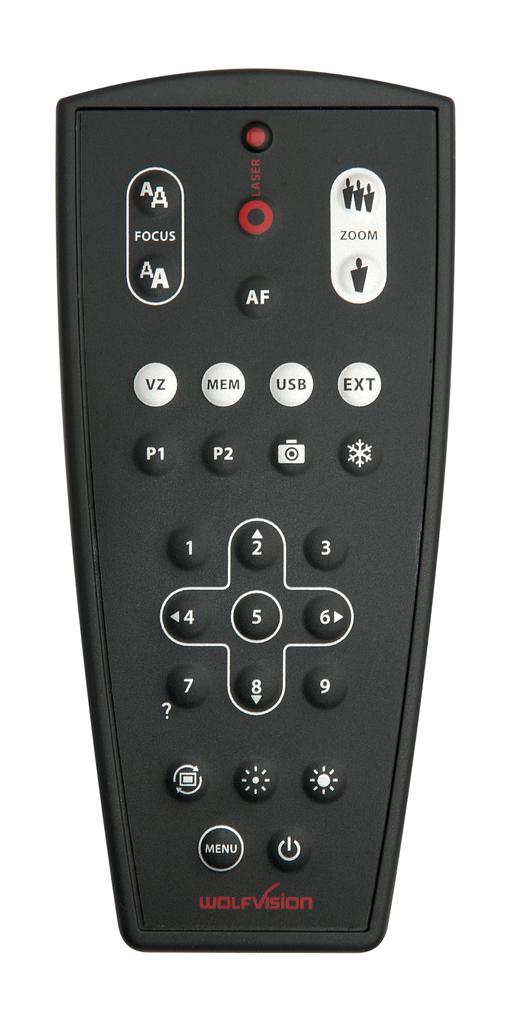Who made this remote?
Ensure brevity in your answer.  Wolfvision. 